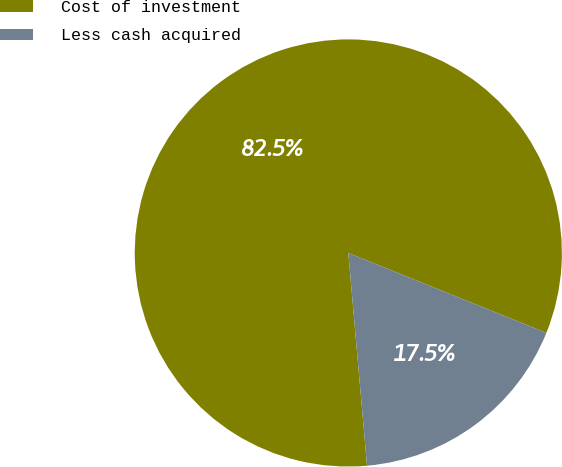<chart> <loc_0><loc_0><loc_500><loc_500><pie_chart><fcel>Cost of investment<fcel>Less cash acquired<nl><fcel>82.5%<fcel>17.5%<nl></chart> 